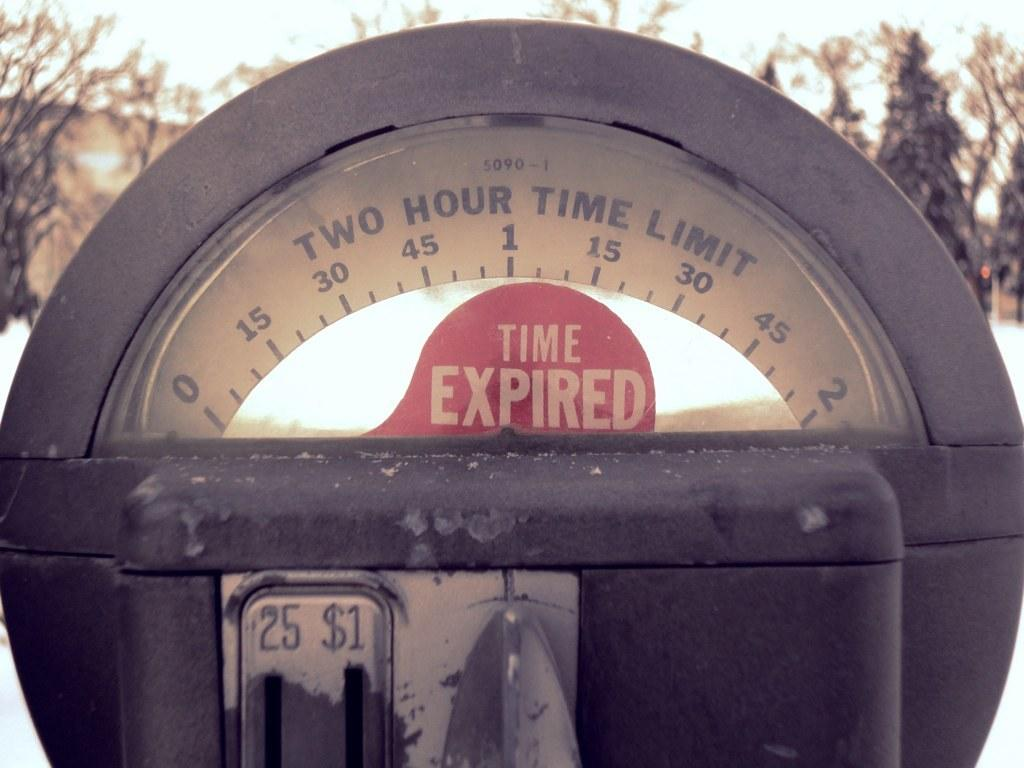<image>
Present a compact description of the photo's key features. A parking meter has the message Time Expired on its display. 